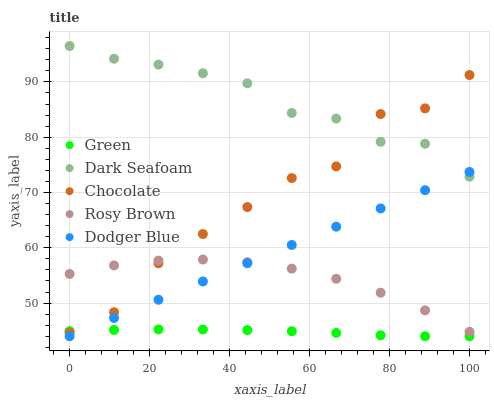Does Green have the minimum area under the curve?
Answer yes or no. Yes. Does Dark Seafoam have the maximum area under the curve?
Answer yes or no. Yes. Does Rosy Brown have the minimum area under the curve?
Answer yes or no. No. Does Rosy Brown have the maximum area under the curve?
Answer yes or no. No. Is Dodger Blue the smoothest?
Answer yes or no. Yes. Is Chocolate the roughest?
Answer yes or no. Yes. Is Dark Seafoam the smoothest?
Answer yes or no. No. Is Dark Seafoam the roughest?
Answer yes or no. No. Does Dodger Blue have the lowest value?
Answer yes or no. Yes. Does Rosy Brown have the lowest value?
Answer yes or no. No. Does Dark Seafoam have the highest value?
Answer yes or no. Yes. Does Rosy Brown have the highest value?
Answer yes or no. No. Is Rosy Brown less than Dark Seafoam?
Answer yes or no. Yes. Is Dark Seafoam greater than Rosy Brown?
Answer yes or no. Yes. Does Dodger Blue intersect Rosy Brown?
Answer yes or no. Yes. Is Dodger Blue less than Rosy Brown?
Answer yes or no. No. Is Dodger Blue greater than Rosy Brown?
Answer yes or no. No. Does Rosy Brown intersect Dark Seafoam?
Answer yes or no. No. 